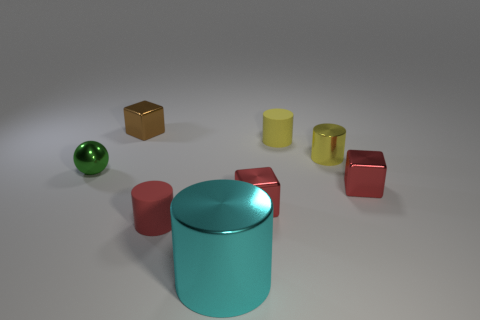Can you describe the objects arranged on the surface and their colors? Certainly! There are several objects of different shapes on the surface. These include a green sphere, a brown cube, a yellow cylinder, a cyan cylinder, and two red cylinders. The different colors and shapes create a visually interesting composition. 